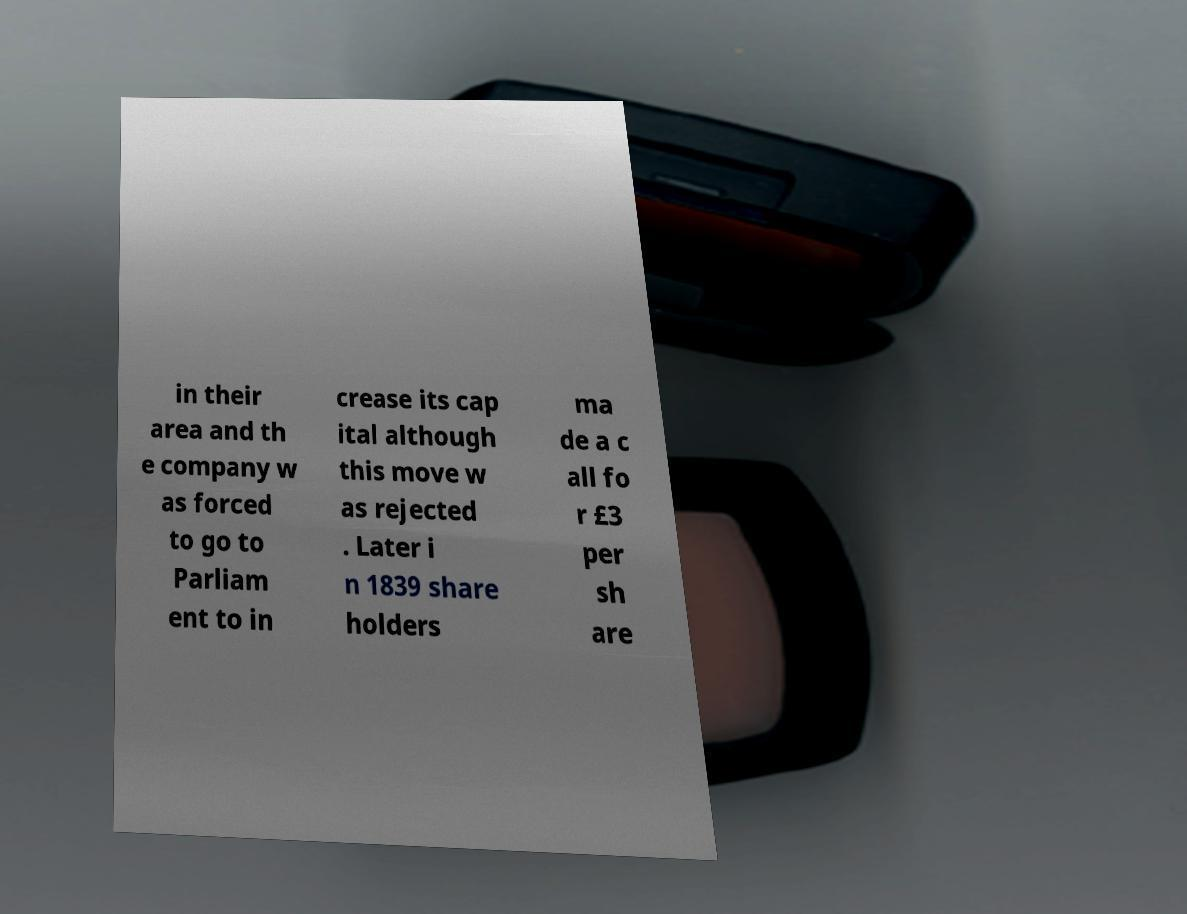What messages or text are displayed in this image? I need them in a readable, typed format. in their area and th e company w as forced to go to Parliam ent to in crease its cap ital although this move w as rejected . Later i n 1839 share holders ma de a c all fo r £3 per sh are 